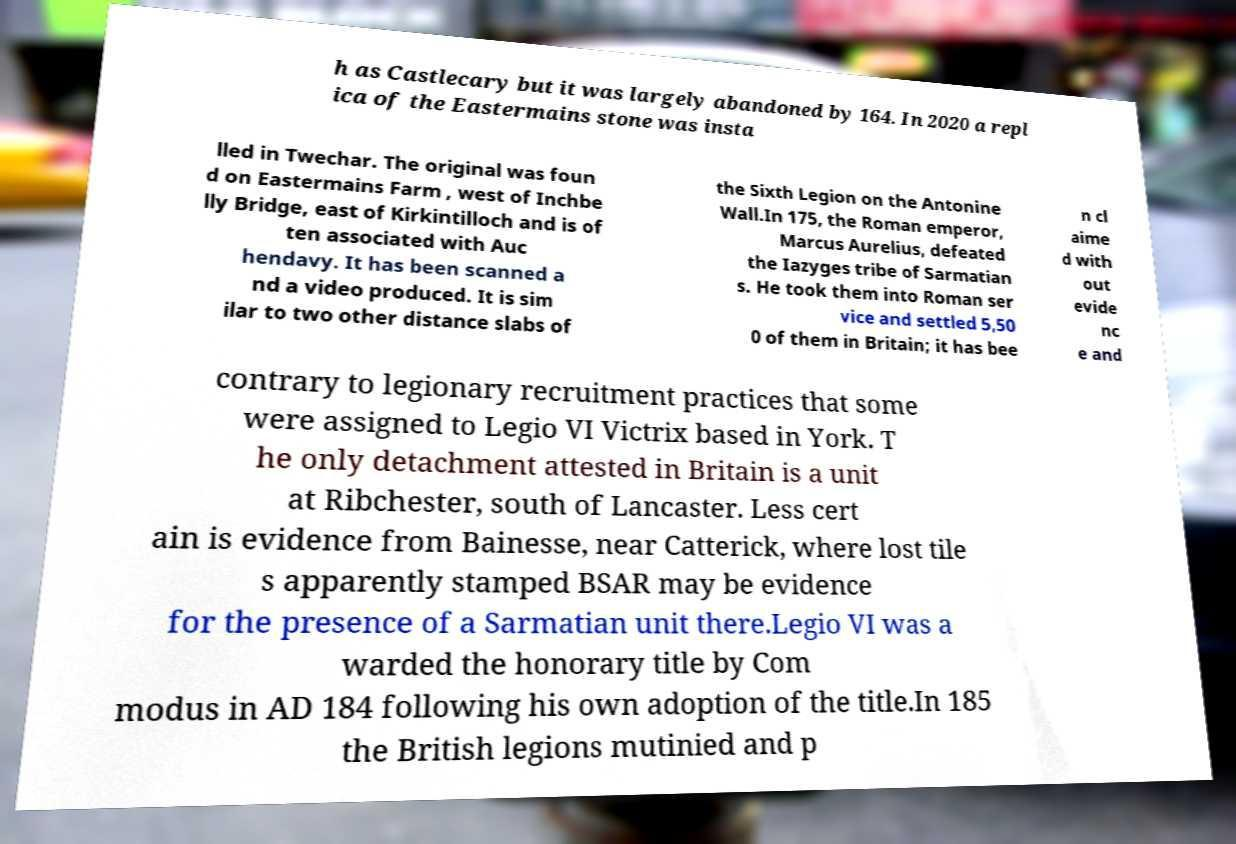What messages or text are displayed in this image? I need them in a readable, typed format. h as Castlecary but it was largely abandoned by 164. In 2020 a repl ica of the Eastermains stone was insta lled in Twechar. The original was foun d on Eastermains Farm , west of Inchbe lly Bridge, east of Kirkintilloch and is of ten associated with Auc hendavy. It has been scanned a nd a video produced. It is sim ilar to two other distance slabs of the Sixth Legion on the Antonine Wall.In 175, the Roman emperor, Marcus Aurelius, defeated the Iazyges tribe of Sarmatian s. He took them into Roman ser vice and settled 5,50 0 of them in Britain; it has bee n cl aime d with out evide nc e and contrary to legionary recruitment practices that some were assigned to Legio VI Victrix based in York. T he only detachment attested in Britain is a unit at Ribchester, south of Lancaster. Less cert ain is evidence from Bainesse, near Catterick, where lost tile s apparently stamped BSAR may be evidence for the presence of a Sarmatian unit there.Legio VI was a warded the honorary title by Com modus in AD 184 following his own adoption of the title.In 185 the British legions mutinied and p 